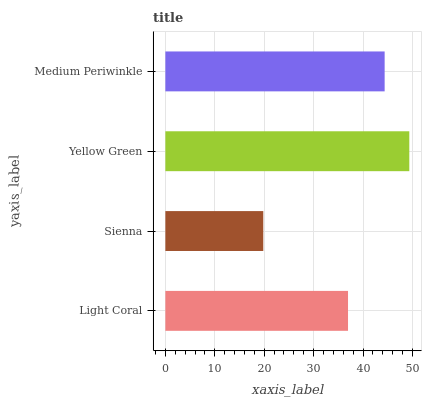Is Sienna the minimum?
Answer yes or no. Yes. Is Yellow Green the maximum?
Answer yes or no. Yes. Is Yellow Green the minimum?
Answer yes or no. No. Is Sienna the maximum?
Answer yes or no. No. Is Yellow Green greater than Sienna?
Answer yes or no. Yes. Is Sienna less than Yellow Green?
Answer yes or no. Yes. Is Sienna greater than Yellow Green?
Answer yes or no. No. Is Yellow Green less than Sienna?
Answer yes or no. No. Is Medium Periwinkle the high median?
Answer yes or no. Yes. Is Light Coral the low median?
Answer yes or no. Yes. Is Light Coral the high median?
Answer yes or no. No. Is Medium Periwinkle the low median?
Answer yes or no. No. 